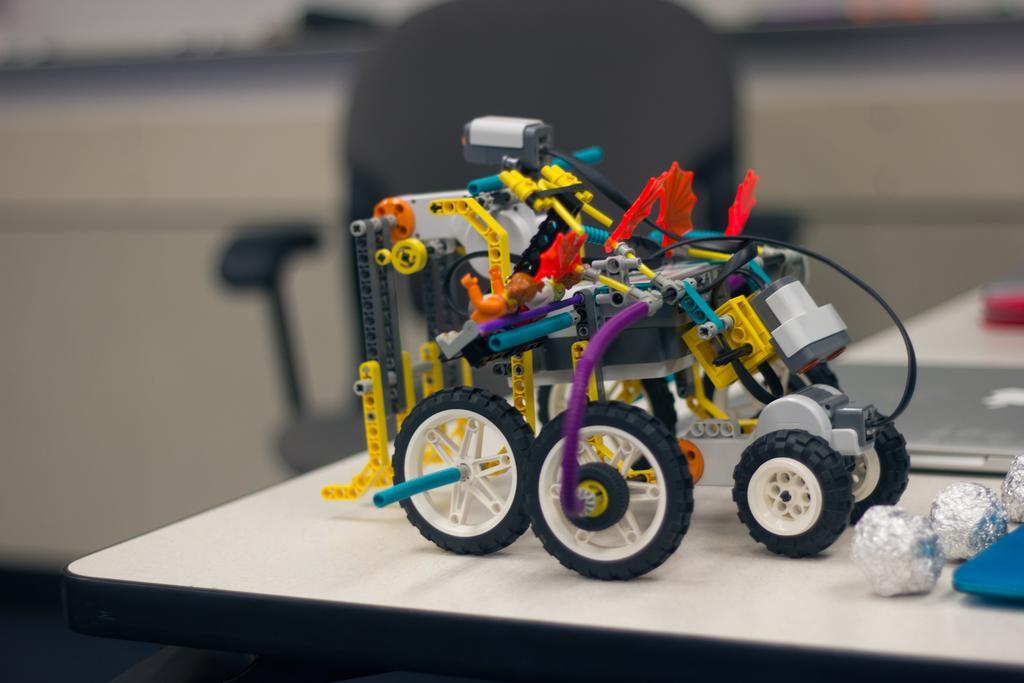In one or two sentences, can you explain what this image depicts? In the picture we can see a desk on it, we can see an electron made vehicle and besides to it, we can see three balls which are silver in color and in the background we can see a chair near the desk which is black in color. 